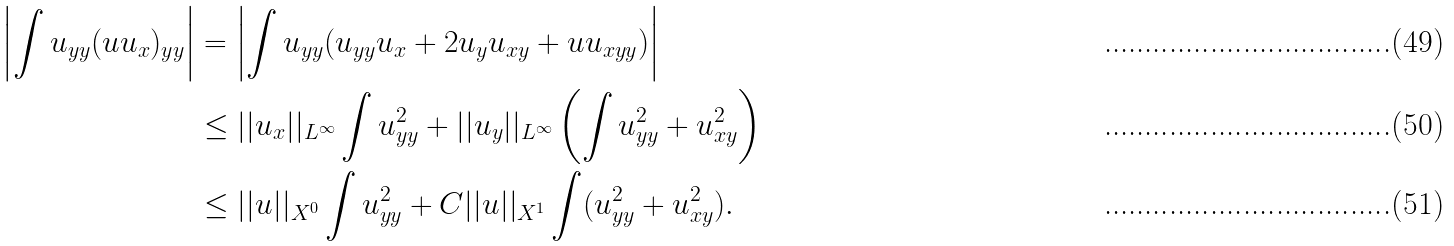<formula> <loc_0><loc_0><loc_500><loc_500>\left | \int u _ { y y } ( u u _ { x } ) _ { y y } \right | & = \left | \int u _ { y y } ( u _ { y y } u _ { x } + 2 u _ { y } u _ { x y } + u u _ { x y y } ) \right | \\ & \leq | | u _ { x } | | _ { L ^ { \infty } } \int u _ { y y } ^ { 2 } + | | u _ { y } | | _ { L ^ { \infty } } \left ( \int u _ { y y } ^ { 2 } + u _ { x y } ^ { 2 } \right ) \\ & \leq | | u | | _ { X ^ { 0 } } \int u _ { y y } ^ { 2 } + C | | u | | _ { X ^ { 1 } } \int ( u _ { y y } ^ { 2 } + u _ { x y } ^ { 2 } ) .</formula> 